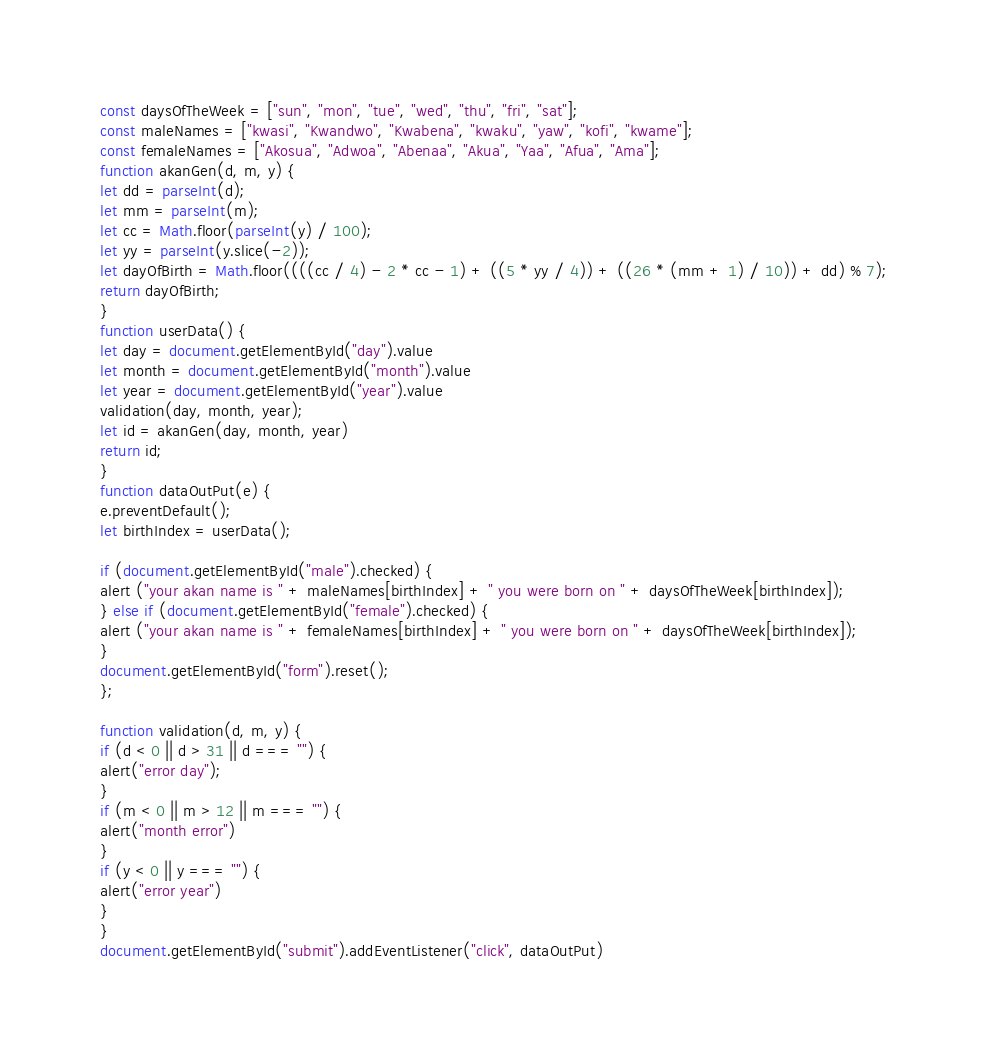Convert code to text. <code><loc_0><loc_0><loc_500><loc_500><_JavaScript_>const daysOfTheWeek = ["sun", "mon", "tue", "wed", "thu", "fri", "sat"];
const maleNames = ["kwasi", "Kwandwo", "Kwabena", "kwaku", "yaw", "kofi", "kwame"];
const femaleNames = ["Akosua", "Adwoa", "Abenaa", "Akua", "Yaa", "Afua", "Ama"];
function akanGen(d, m, y) {
let dd = parseInt(d);
let mm = parseInt(m);
let cc = Math.floor(parseInt(y) / 100);
let yy = parseInt(y.slice(-2));
let dayOfBirth = Math.floor((((cc / 4) - 2 * cc - 1) + ((5 * yy / 4)) + ((26 * (mm + 1) / 10)) + dd) % 7);
return dayOfBirth;
}
function userData() {
let day = document.getElementById("day").value
let month = document.getElementById("month").value
let year = document.getElementById("year").value
validation(day, month, year);
let id = akanGen(day, month, year)
return id;
}
function dataOutPut(e) {
e.preventDefault();
let birthIndex = userData();

if (document.getElementById("male").checked) {
alert ("your akan name is " + maleNames[birthIndex] + " you were born on " + daysOfTheWeek[birthIndex]);
} else if (document.getElementById("female").checked) {
alert ("your akan name is " + femaleNames[birthIndex] + " you were born on " + daysOfTheWeek[birthIndex]);
}
document.getElementById("form").reset();
};

function validation(d, m, y) {
if (d < 0 || d > 31 || d === "") {
alert("error day");
}
if (m < 0 || m > 12 || m === "") {
alert("month error")
}
if (y < 0 || y === "") {
alert("error year")
}
}
document.getElementById("submit").addEventListener("click", dataOutPut)</code> 